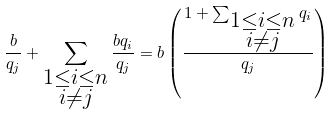Convert formula to latex. <formula><loc_0><loc_0><loc_500><loc_500>\frac { b } { q _ { j } } + \sum _ { \substack { 1 \leq i \leq n \\ i \neq j } } \frac { b q _ { i } } { q _ { j } } = b \left ( \frac { 1 + \sum _ { \substack { 1 \leq i \leq n \\ i \neq j } } q _ { i } } { q _ { j } } \right )</formula> 